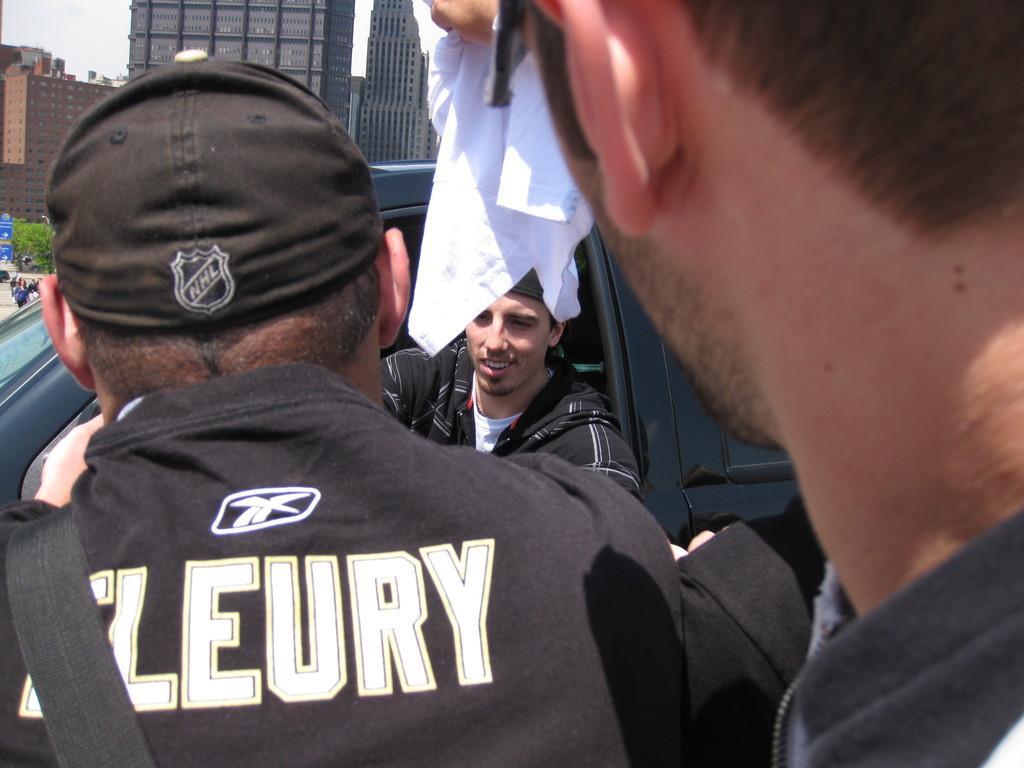How would you summarize this image in a sentence or two? In this picture I can see there are three men, the man on top right side is holding a kerchief and the person at left side is wearing a cap with a logo, the coat and there is something written on it, he is wearing a bag, there is another person sitting in the car and smiling. In the backdrop, I can see there are few plants, buildings with glass windows and the sky is clear. 